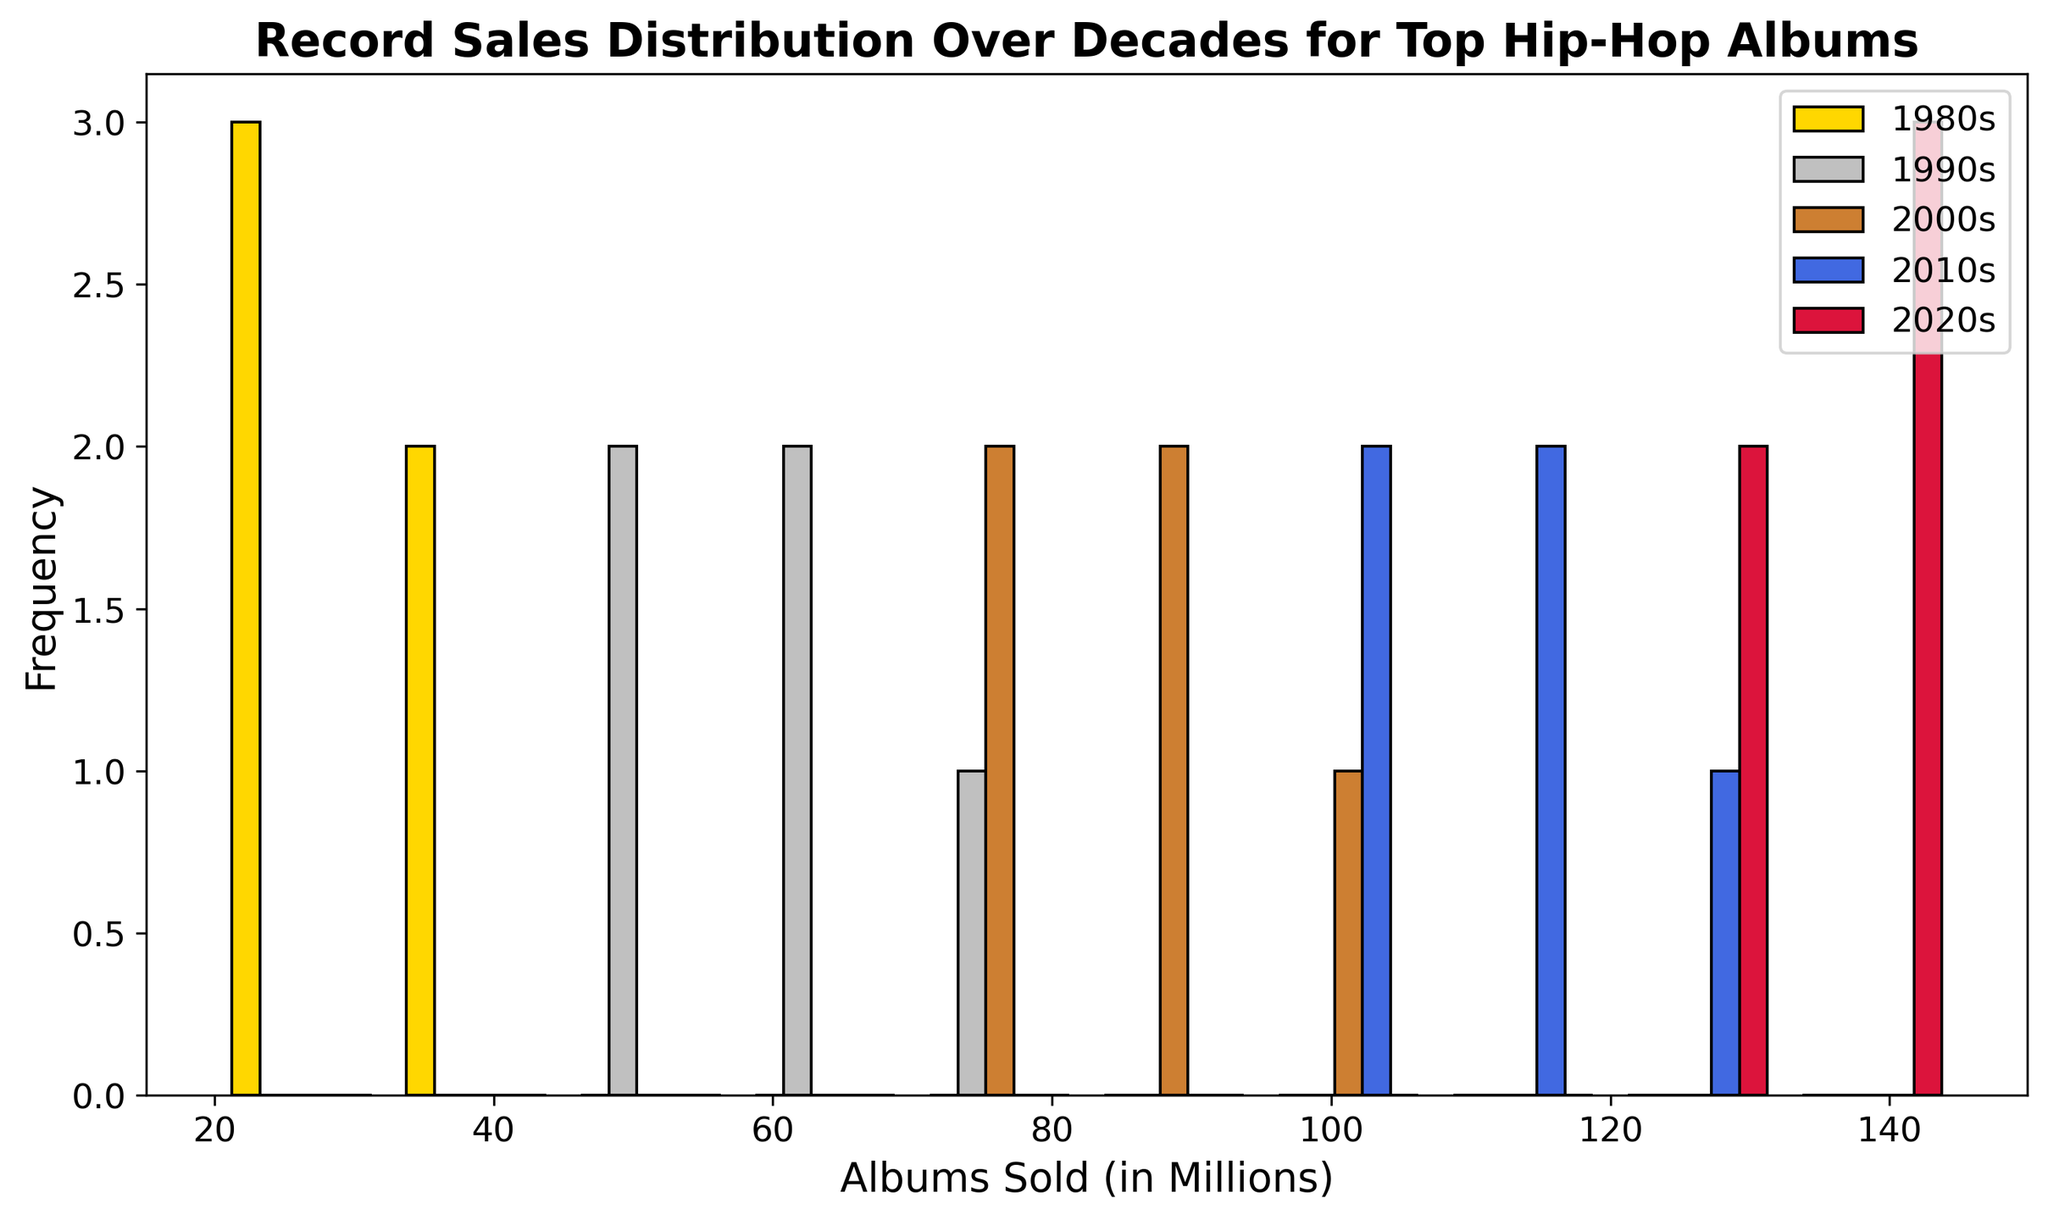What is the most frequent range of albums sold in the 1980s? The 1980s histogram bar with the highest frequency should indicate the most common range. Identify the decade color, then locate the tallest bar for that color.
Answer: 30-40 million Which decade has the highest sales frequency at the upper end of album sales? To find this, identify the tallest bar among the bins with higher album sales across all decades. The bar for the decade with the topmost height at this range will indicate the highest sales frequency.
Answer: 2020s How does the distribution of albums sold in the 1990s compare to those in the 2000s? Compare the height and spread of the histogram bars for the 1990s and 2000s. Note which decade has higher or more spread-out frequencies.
Answer: The 2000s have a broader spread and higher frequency of more albums sold What is the average number of albums sold in the 2000s? Sum the album sales in the 2000s and divide by the number of entries. Calculate (75 + 80 + 90 + 85 + 95) / 5 = 85
Answer: 85 million What decade shows the most consistent number of album sales? Consistency is indicated by less spread in the histogram bars. Determine which decade's bars are closest in height.
Answer: 1980s Are there any decades with overlapping ranges of album sales? Identify if any histogram bars of different colors overlap within the same bins.
Answer: Yes Which decade has the greatest total album sales? Sum the album sales for each decade: 1980s: 150; 1990s: 295; 2000s: 425; 2010s: 550; 2020s: 675. Determine the highest.
Answer: 2020s What is the median value of albums sold in the 2010s? Sort the album sales values in the 2010s (100, 105, 110, 115, 120), the median is the middle value: 105
Answer: 105 million Which decade's histogram bars are widest across different sales categories? Identify which decade's bars span across the most number of bins. This involves observing the spread of the bar colors.
Answer: 2020s 